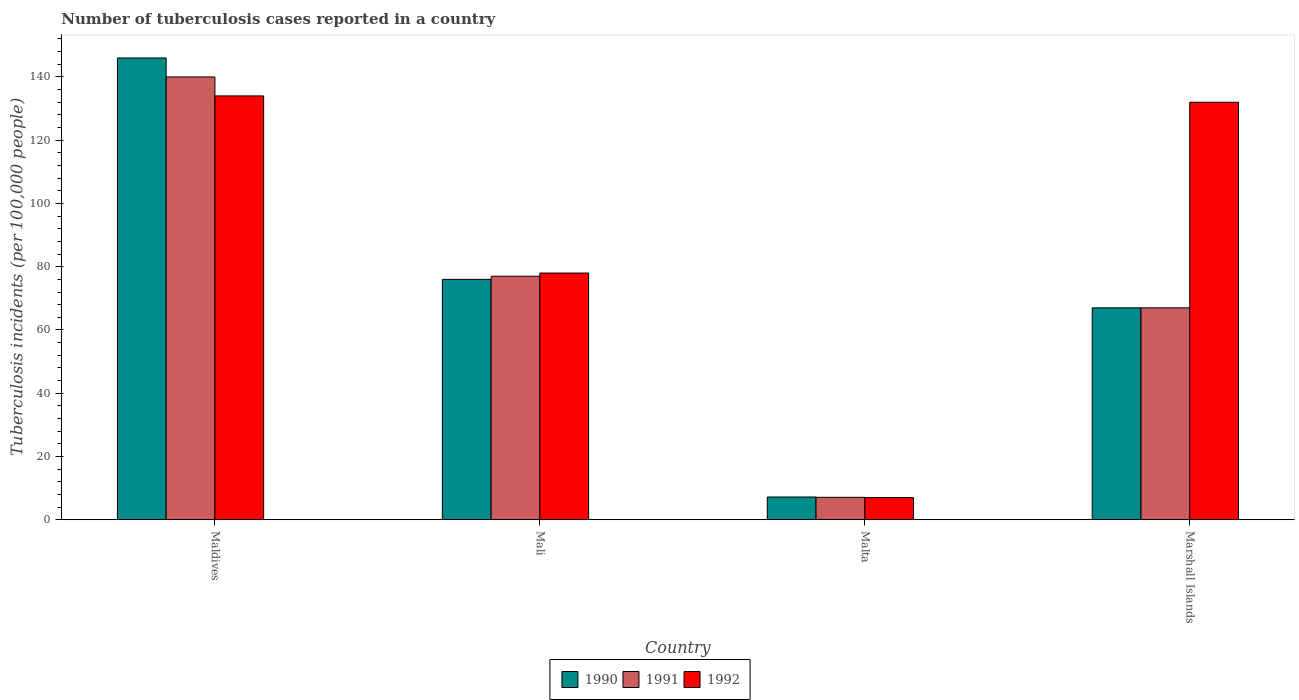Are the number of bars per tick equal to the number of legend labels?
Make the answer very short. Yes. Are the number of bars on each tick of the X-axis equal?
Give a very brief answer. Yes. How many bars are there on the 2nd tick from the left?
Ensure brevity in your answer.  3. What is the label of the 2nd group of bars from the left?
Offer a very short reply. Mali. In how many cases, is the number of bars for a given country not equal to the number of legend labels?
Ensure brevity in your answer.  0. What is the number of tuberculosis cases reported in in 1991 in Maldives?
Provide a succinct answer. 140. Across all countries, what is the maximum number of tuberculosis cases reported in in 1991?
Give a very brief answer. 140. In which country was the number of tuberculosis cases reported in in 1992 maximum?
Provide a short and direct response. Maldives. In which country was the number of tuberculosis cases reported in in 1991 minimum?
Ensure brevity in your answer.  Malta. What is the total number of tuberculosis cases reported in in 1991 in the graph?
Provide a short and direct response. 291.1. What is the difference between the number of tuberculosis cases reported in in 1991 in Malta and that in Marshall Islands?
Keep it short and to the point. -59.9. What is the difference between the number of tuberculosis cases reported in in 1991 in Marshall Islands and the number of tuberculosis cases reported in in 1990 in Maldives?
Offer a terse response. -79. What is the average number of tuberculosis cases reported in in 1990 per country?
Give a very brief answer. 74.05. What is the difference between the number of tuberculosis cases reported in of/in 1991 and number of tuberculosis cases reported in of/in 1990 in Maldives?
Offer a very short reply. -6. What is the ratio of the number of tuberculosis cases reported in in 1992 in Malta to that in Marshall Islands?
Provide a succinct answer. 0.05. What is the difference between the highest and the second highest number of tuberculosis cases reported in in 1990?
Offer a very short reply. 79. What is the difference between the highest and the lowest number of tuberculosis cases reported in in 1991?
Offer a terse response. 132.9. In how many countries, is the number of tuberculosis cases reported in in 1992 greater than the average number of tuberculosis cases reported in in 1992 taken over all countries?
Give a very brief answer. 2. What does the 1st bar from the left in Marshall Islands represents?
Provide a short and direct response. 1990. Is it the case that in every country, the sum of the number of tuberculosis cases reported in in 1992 and number of tuberculosis cases reported in in 1990 is greater than the number of tuberculosis cases reported in in 1991?
Make the answer very short. Yes. How many countries are there in the graph?
Your answer should be very brief. 4. Are the values on the major ticks of Y-axis written in scientific E-notation?
Provide a succinct answer. No. How many legend labels are there?
Offer a terse response. 3. How are the legend labels stacked?
Your answer should be compact. Horizontal. What is the title of the graph?
Offer a very short reply. Number of tuberculosis cases reported in a country. Does "1989" appear as one of the legend labels in the graph?
Provide a succinct answer. No. What is the label or title of the Y-axis?
Offer a terse response. Tuberculosis incidents (per 100,0 people). What is the Tuberculosis incidents (per 100,000 people) of 1990 in Maldives?
Give a very brief answer. 146. What is the Tuberculosis incidents (per 100,000 people) in 1991 in Maldives?
Offer a terse response. 140. What is the Tuberculosis incidents (per 100,000 people) in 1992 in Maldives?
Keep it short and to the point. 134. What is the Tuberculosis incidents (per 100,000 people) in 1990 in Mali?
Your response must be concise. 76. What is the Tuberculosis incidents (per 100,000 people) in 1992 in Mali?
Your answer should be compact. 78. What is the Tuberculosis incidents (per 100,000 people) in 1990 in Malta?
Provide a succinct answer. 7.2. What is the Tuberculosis incidents (per 100,000 people) in 1991 in Malta?
Provide a succinct answer. 7.1. What is the Tuberculosis incidents (per 100,000 people) of 1992 in Malta?
Offer a very short reply. 7. What is the Tuberculosis incidents (per 100,000 people) of 1992 in Marshall Islands?
Give a very brief answer. 132. Across all countries, what is the maximum Tuberculosis incidents (per 100,000 people) of 1990?
Your answer should be compact. 146. Across all countries, what is the maximum Tuberculosis incidents (per 100,000 people) in 1991?
Make the answer very short. 140. Across all countries, what is the maximum Tuberculosis incidents (per 100,000 people) in 1992?
Keep it short and to the point. 134. Across all countries, what is the minimum Tuberculosis incidents (per 100,000 people) in 1991?
Your response must be concise. 7.1. Across all countries, what is the minimum Tuberculosis incidents (per 100,000 people) of 1992?
Offer a terse response. 7. What is the total Tuberculosis incidents (per 100,000 people) in 1990 in the graph?
Offer a terse response. 296.2. What is the total Tuberculosis incidents (per 100,000 people) of 1991 in the graph?
Provide a short and direct response. 291.1. What is the total Tuberculosis incidents (per 100,000 people) in 1992 in the graph?
Keep it short and to the point. 351. What is the difference between the Tuberculosis incidents (per 100,000 people) of 1990 in Maldives and that in Mali?
Provide a short and direct response. 70. What is the difference between the Tuberculosis incidents (per 100,000 people) in 1991 in Maldives and that in Mali?
Ensure brevity in your answer.  63. What is the difference between the Tuberculosis incidents (per 100,000 people) of 1990 in Maldives and that in Malta?
Your response must be concise. 138.8. What is the difference between the Tuberculosis incidents (per 100,000 people) of 1991 in Maldives and that in Malta?
Provide a short and direct response. 132.9. What is the difference between the Tuberculosis incidents (per 100,000 people) in 1992 in Maldives and that in Malta?
Make the answer very short. 127. What is the difference between the Tuberculosis incidents (per 100,000 people) of 1990 in Maldives and that in Marshall Islands?
Ensure brevity in your answer.  79. What is the difference between the Tuberculosis incidents (per 100,000 people) of 1991 in Maldives and that in Marshall Islands?
Your answer should be compact. 73. What is the difference between the Tuberculosis incidents (per 100,000 people) in 1992 in Maldives and that in Marshall Islands?
Your answer should be compact. 2. What is the difference between the Tuberculosis incidents (per 100,000 people) of 1990 in Mali and that in Malta?
Offer a very short reply. 68.8. What is the difference between the Tuberculosis incidents (per 100,000 people) in 1991 in Mali and that in Malta?
Offer a very short reply. 69.9. What is the difference between the Tuberculosis incidents (per 100,000 people) of 1991 in Mali and that in Marshall Islands?
Offer a terse response. 10. What is the difference between the Tuberculosis incidents (per 100,000 people) in 1992 in Mali and that in Marshall Islands?
Keep it short and to the point. -54. What is the difference between the Tuberculosis incidents (per 100,000 people) of 1990 in Malta and that in Marshall Islands?
Make the answer very short. -59.8. What is the difference between the Tuberculosis incidents (per 100,000 people) in 1991 in Malta and that in Marshall Islands?
Offer a terse response. -59.9. What is the difference between the Tuberculosis incidents (per 100,000 people) of 1992 in Malta and that in Marshall Islands?
Keep it short and to the point. -125. What is the difference between the Tuberculosis incidents (per 100,000 people) of 1990 in Maldives and the Tuberculosis incidents (per 100,000 people) of 1992 in Mali?
Provide a succinct answer. 68. What is the difference between the Tuberculosis incidents (per 100,000 people) of 1991 in Maldives and the Tuberculosis incidents (per 100,000 people) of 1992 in Mali?
Provide a short and direct response. 62. What is the difference between the Tuberculosis incidents (per 100,000 people) of 1990 in Maldives and the Tuberculosis incidents (per 100,000 people) of 1991 in Malta?
Your answer should be compact. 138.9. What is the difference between the Tuberculosis incidents (per 100,000 people) in 1990 in Maldives and the Tuberculosis incidents (per 100,000 people) in 1992 in Malta?
Offer a very short reply. 139. What is the difference between the Tuberculosis incidents (per 100,000 people) of 1991 in Maldives and the Tuberculosis incidents (per 100,000 people) of 1992 in Malta?
Ensure brevity in your answer.  133. What is the difference between the Tuberculosis incidents (per 100,000 people) in 1990 in Maldives and the Tuberculosis incidents (per 100,000 people) in 1991 in Marshall Islands?
Your answer should be compact. 79. What is the difference between the Tuberculosis incidents (per 100,000 people) in 1990 in Maldives and the Tuberculosis incidents (per 100,000 people) in 1992 in Marshall Islands?
Provide a succinct answer. 14. What is the difference between the Tuberculosis incidents (per 100,000 people) of 1990 in Mali and the Tuberculosis incidents (per 100,000 people) of 1991 in Malta?
Make the answer very short. 68.9. What is the difference between the Tuberculosis incidents (per 100,000 people) in 1991 in Mali and the Tuberculosis incidents (per 100,000 people) in 1992 in Malta?
Give a very brief answer. 70. What is the difference between the Tuberculosis incidents (per 100,000 people) in 1990 in Mali and the Tuberculosis incidents (per 100,000 people) in 1992 in Marshall Islands?
Ensure brevity in your answer.  -56. What is the difference between the Tuberculosis incidents (per 100,000 people) in 1991 in Mali and the Tuberculosis incidents (per 100,000 people) in 1992 in Marshall Islands?
Your answer should be compact. -55. What is the difference between the Tuberculosis incidents (per 100,000 people) of 1990 in Malta and the Tuberculosis incidents (per 100,000 people) of 1991 in Marshall Islands?
Ensure brevity in your answer.  -59.8. What is the difference between the Tuberculosis incidents (per 100,000 people) in 1990 in Malta and the Tuberculosis incidents (per 100,000 people) in 1992 in Marshall Islands?
Give a very brief answer. -124.8. What is the difference between the Tuberculosis incidents (per 100,000 people) in 1991 in Malta and the Tuberculosis incidents (per 100,000 people) in 1992 in Marshall Islands?
Your response must be concise. -124.9. What is the average Tuberculosis incidents (per 100,000 people) of 1990 per country?
Provide a short and direct response. 74.05. What is the average Tuberculosis incidents (per 100,000 people) of 1991 per country?
Offer a very short reply. 72.78. What is the average Tuberculosis incidents (per 100,000 people) of 1992 per country?
Provide a succinct answer. 87.75. What is the difference between the Tuberculosis incidents (per 100,000 people) in 1990 and Tuberculosis incidents (per 100,000 people) in 1991 in Maldives?
Give a very brief answer. 6. What is the difference between the Tuberculosis incidents (per 100,000 people) in 1991 and Tuberculosis incidents (per 100,000 people) in 1992 in Mali?
Keep it short and to the point. -1. What is the difference between the Tuberculosis incidents (per 100,000 people) in 1990 and Tuberculosis incidents (per 100,000 people) in 1991 in Malta?
Offer a terse response. 0.1. What is the difference between the Tuberculosis incidents (per 100,000 people) of 1991 and Tuberculosis incidents (per 100,000 people) of 1992 in Malta?
Your response must be concise. 0.1. What is the difference between the Tuberculosis incidents (per 100,000 people) in 1990 and Tuberculosis incidents (per 100,000 people) in 1992 in Marshall Islands?
Offer a terse response. -65. What is the difference between the Tuberculosis incidents (per 100,000 people) in 1991 and Tuberculosis incidents (per 100,000 people) in 1992 in Marshall Islands?
Keep it short and to the point. -65. What is the ratio of the Tuberculosis incidents (per 100,000 people) of 1990 in Maldives to that in Mali?
Provide a succinct answer. 1.92. What is the ratio of the Tuberculosis incidents (per 100,000 people) in 1991 in Maldives to that in Mali?
Provide a short and direct response. 1.82. What is the ratio of the Tuberculosis incidents (per 100,000 people) of 1992 in Maldives to that in Mali?
Your answer should be compact. 1.72. What is the ratio of the Tuberculosis incidents (per 100,000 people) in 1990 in Maldives to that in Malta?
Make the answer very short. 20.28. What is the ratio of the Tuberculosis incidents (per 100,000 people) in 1991 in Maldives to that in Malta?
Your answer should be compact. 19.72. What is the ratio of the Tuberculosis incidents (per 100,000 people) in 1992 in Maldives to that in Malta?
Your response must be concise. 19.14. What is the ratio of the Tuberculosis incidents (per 100,000 people) in 1990 in Maldives to that in Marshall Islands?
Offer a terse response. 2.18. What is the ratio of the Tuberculosis incidents (per 100,000 people) in 1991 in Maldives to that in Marshall Islands?
Your answer should be very brief. 2.09. What is the ratio of the Tuberculosis incidents (per 100,000 people) of 1992 in Maldives to that in Marshall Islands?
Your response must be concise. 1.02. What is the ratio of the Tuberculosis incidents (per 100,000 people) in 1990 in Mali to that in Malta?
Offer a terse response. 10.56. What is the ratio of the Tuberculosis incidents (per 100,000 people) of 1991 in Mali to that in Malta?
Ensure brevity in your answer.  10.85. What is the ratio of the Tuberculosis incidents (per 100,000 people) of 1992 in Mali to that in Malta?
Your response must be concise. 11.14. What is the ratio of the Tuberculosis incidents (per 100,000 people) of 1990 in Mali to that in Marshall Islands?
Ensure brevity in your answer.  1.13. What is the ratio of the Tuberculosis incidents (per 100,000 people) of 1991 in Mali to that in Marshall Islands?
Make the answer very short. 1.15. What is the ratio of the Tuberculosis incidents (per 100,000 people) in 1992 in Mali to that in Marshall Islands?
Your response must be concise. 0.59. What is the ratio of the Tuberculosis incidents (per 100,000 people) in 1990 in Malta to that in Marshall Islands?
Your answer should be very brief. 0.11. What is the ratio of the Tuberculosis incidents (per 100,000 people) of 1991 in Malta to that in Marshall Islands?
Your answer should be compact. 0.11. What is the ratio of the Tuberculosis incidents (per 100,000 people) in 1992 in Malta to that in Marshall Islands?
Your answer should be very brief. 0.05. What is the difference between the highest and the second highest Tuberculosis incidents (per 100,000 people) of 1992?
Ensure brevity in your answer.  2. What is the difference between the highest and the lowest Tuberculosis incidents (per 100,000 people) of 1990?
Ensure brevity in your answer.  138.8. What is the difference between the highest and the lowest Tuberculosis incidents (per 100,000 people) in 1991?
Offer a terse response. 132.9. What is the difference between the highest and the lowest Tuberculosis incidents (per 100,000 people) in 1992?
Your answer should be compact. 127. 